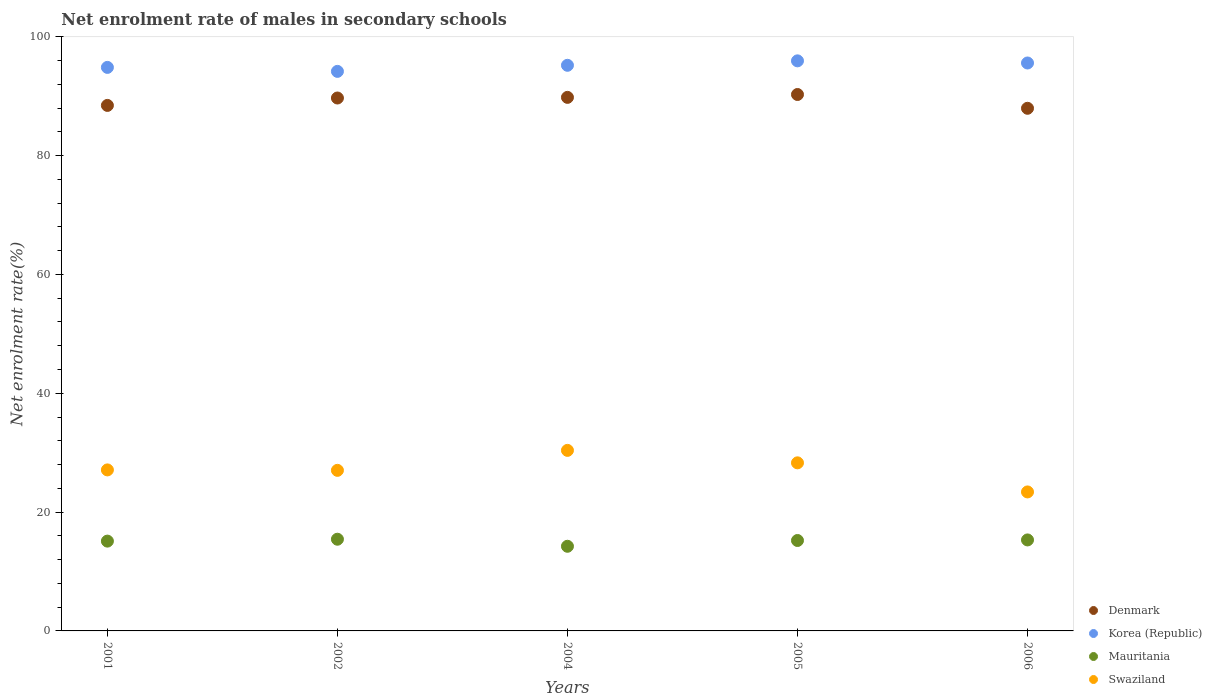How many different coloured dotlines are there?
Ensure brevity in your answer.  4. Is the number of dotlines equal to the number of legend labels?
Offer a terse response. Yes. What is the net enrolment rate of males in secondary schools in Korea (Republic) in 2002?
Offer a very short reply. 94.18. Across all years, what is the maximum net enrolment rate of males in secondary schools in Mauritania?
Provide a succinct answer. 15.43. Across all years, what is the minimum net enrolment rate of males in secondary schools in Swaziland?
Provide a succinct answer. 23.39. In which year was the net enrolment rate of males in secondary schools in Korea (Republic) maximum?
Offer a terse response. 2005. In which year was the net enrolment rate of males in secondary schools in Korea (Republic) minimum?
Provide a succinct answer. 2002. What is the total net enrolment rate of males in secondary schools in Denmark in the graph?
Your response must be concise. 446.19. What is the difference between the net enrolment rate of males in secondary schools in Swaziland in 2001 and that in 2002?
Your answer should be very brief. 0.07. What is the difference between the net enrolment rate of males in secondary schools in Swaziland in 2004 and the net enrolment rate of males in secondary schools in Mauritania in 2005?
Provide a short and direct response. 15.17. What is the average net enrolment rate of males in secondary schools in Denmark per year?
Your answer should be very brief. 89.24. In the year 2001, what is the difference between the net enrolment rate of males in secondary schools in Mauritania and net enrolment rate of males in secondary schools in Swaziland?
Offer a very short reply. -11.99. In how many years, is the net enrolment rate of males in secondary schools in Korea (Republic) greater than 12 %?
Ensure brevity in your answer.  5. What is the ratio of the net enrolment rate of males in secondary schools in Mauritania in 2005 to that in 2006?
Your answer should be very brief. 0.99. Is the difference between the net enrolment rate of males in secondary schools in Mauritania in 2002 and 2004 greater than the difference between the net enrolment rate of males in secondary schools in Swaziland in 2002 and 2004?
Give a very brief answer. Yes. What is the difference between the highest and the second highest net enrolment rate of males in secondary schools in Mauritania?
Your answer should be very brief. 0.12. What is the difference between the highest and the lowest net enrolment rate of males in secondary schools in Mauritania?
Provide a succinct answer. 1.19. Is the sum of the net enrolment rate of males in secondary schools in Mauritania in 2004 and 2005 greater than the maximum net enrolment rate of males in secondary schools in Swaziland across all years?
Offer a terse response. No. How many dotlines are there?
Ensure brevity in your answer.  4. How many years are there in the graph?
Give a very brief answer. 5. Are the values on the major ticks of Y-axis written in scientific E-notation?
Offer a very short reply. No. Does the graph contain grids?
Offer a terse response. No. What is the title of the graph?
Offer a terse response. Net enrolment rate of males in secondary schools. Does "Bhutan" appear as one of the legend labels in the graph?
Keep it short and to the point. No. What is the label or title of the X-axis?
Ensure brevity in your answer.  Years. What is the label or title of the Y-axis?
Your answer should be very brief. Net enrolment rate(%). What is the Net enrolment rate(%) of Denmark in 2001?
Offer a terse response. 88.45. What is the Net enrolment rate(%) in Korea (Republic) in 2001?
Your response must be concise. 94.85. What is the Net enrolment rate(%) of Mauritania in 2001?
Your response must be concise. 15.11. What is the Net enrolment rate(%) of Swaziland in 2001?
Your answer should be compact. 27.1. What is the Net enrolment rate(%) in Denmark in 2002?
Provide a short and direct response. 89.69. What is the Net enrolment rate(%) in Korea (Republic) in 2002?
Provide a short and direct response. 94.18. What is the Net enrolment rate(%) of Mauritania in 2002?
Your answer should be compact. 15.43. What is the Net enrolment rate(%) of Swaziland in 2002?
Make the answer very short. 27.03. What is the Net enrolment rate(%) of Denmark in 2004?
Offer a very short reply. 89.8. What is the Net enrolment rate(%) in Korea (Republic) in 2004?
Your answer should be compact. 95.2. What is the Net enrolment rate(%) of Mauritania in 2004?
Make the answer very short. 14.25. What is the Net enrolment rate(%) of Swaziland in 2004?
Ensure brevity in your answer.  30.39. What is the Net enrolment rate(%) in Denmark in 2005?
Your answer should be compact. 90.28. What is the Net enrolment rate(%) in Korea (Republic) in 2005?
Provide a short and direct response. 95.95. What is the Net enrolment rate(%) in Mauritania in 2005?
Your answer should be compact. 15.22. What is the Net enrolment rate(%) of Swaziland in 2005?
Make the answer very short. 28.29. What is the Net enrolment rate(%) of Denmark in 2006?
Provide a succinct answer. 87.96. What is the Net enrolment rate(%) of Korea (Republic) in 2006?
Offer a very short reply. 95.59. What is the Net enrolment rate(%) of Mauritania in 2006?
Your answer should be very brief. 15.31. What is the Net enrolment rate(%) of Swaziland in 2006?
Your answer should be very brief. 23.39. Across all years, what is the maximum Net enrolment rate(%) in Denmark?
Provide a succinct answer. 90.28. Across all years, what is the maximum Net enrolment rate(%) of Korea (Republic)?
Ensure brevity in your answer.  95.95. Across all years, what is the maximum Net enrolment rate(%) in Mauritania?
Your answer should be very brief. 15.43. Across all years, what is the maximum Net enrolment rate(%) of Swaziland?
Your response must be concise. 30.39. Across all years, what is the minimum Net enrolment rate(%) of Denmark?
Keep it short and to the point. 87.96. Across all years, what is the minimum Net enrolment rate(%) in Korea (Republic)?
Provide a short and direct response. 94.18. Across all years, what is the minimum Net enrolment rate(%) in Mauritania?
Your answer should be compact. 14.25. Across all years, what is the minimum Net enrolment rate(%) of Swaziland?
Keep it short and to the point. 23.39. What is the total Net enrolment rate(%) of Denmark in the graph?
Make the answer very short. 446.19. What is the total Net enrolment rate(%) in Korea (Republic) in the graph?
Ensure brevity in your answer.  475.75. What is the total Net enrolment rate(%) of Mauritania in the graph?
Provide a short and direct response. 75.33. What is the total Net enrolment rate(%) in Swaziland in the graph?
Make the answer very short. 136.19. What is the difference between the Net enrolment rate(%) of Denmark in 2001 and that in 2002?
Offer a very short reply. -1.25. What is the difference between the Net enrolment rate(%) of Korea (Republic) in 2001 and that in 2002?
Provide a succinct answer. 0.67. What is the difference between the Net enrolment rate(%) in Mauritania in 2001 and that in 2002?
Your answer should be compact. -0.32. What is the difference between the Net enrolment rate(%) in Swaziland in 2001 and that in 2002?
Ensure brevity in your answer.  0.07. What is the difference between the Net enrolment rate(%) of Denmark in 2001 and that in 2004?
Offer a very short reply. -1.35. What is the difference between the Net enrolment rate(%) of Korea (Republic) in 2001 and that in 2004?
Offer a terse response. -0.35. What is the difference between the Net enrolment rate(%) of Mauritania in 2001 and that in 2004?
Your answer should be compact. 0.87. What is the difference between the Net enrolment rate(%) in Swaziland in 2001 and that in 2004?
Provide a succinct answer. -3.29. What is the difference between the Net enrolment rate(%) of Denmark in 2001 and that in 2005?
Make the answer very short. -1.84. What is the difference between the Net enrolment rate(%) of Korea (Republic) in 2001 and that in 2005?
Your response must be concise. -1.1. What is the difference between the Net enrolment rate(%) of Mauritania in 2001 and that in 2005?
Keep it short and to the point. -0.1. What is the difference between the Net enrolment rate(%) in Swaziland in 2001 and that in 2005?
Keep it short and to the point. -1.19. What is the difference between the Net enrolment rate(%) in Denmark in 2001 and that in 2006?
Offer a very short reply. 0.48. What is the difference between the Net enrolment rate(%) in Korea (Republic) in 2001 and that in 2006?
Give a very brief answer. -0.74. What is the difference between the Net enrolment rate(%) in Mauritania in 2001 and that in 2006?
Keep it short and to the point. -0.2. What is the difference between the Net enrolment rate(%) of Swaziland in 2001 and that in 2006?
Provide a short and direct response. 3.71. What is the difference between the Net enrolment rate(%) of Denmark in 2002 and that in 2004?
Keep it short and to the point. -0.11. What is the difference between the Net enrolment rate(%) in Korea (Republic) in 2002 and that in 2004?
Ensure brevity in your answer.  -1.02. What is the difference between the Net enrolment rate(%) in Mauritania in 2002 and that in 2004?
Give a very brief answer. 1.19. What is the difference between the Net enrolment rate(%) in Swaziland in 2002 and that in 2004?
Offer a very short reply. -3.36. What is the difference between the Net enrolment rate(%) of Denmark in 2002 and that in 2005?
Ensure brevity in your answer.  -0.59. What is the difference between the Net enrolment rate(%) in Korea (Republic) in 2002 and that in 2005?
Make the answer very short. -1.77. What is the difference between the Net enrolment rate(%) of Mauritania in 2002 and that in 2005?
Keep it short and to the point. 0.21. What is the difference between the Net enrolment rate(%) in Swaziland in 2002 and that in 2005?
Ensure brevity in your answer.  -1.26. What is the difference between the Net enrolment rate(%) in Denmark in 2002 and that in 2006?
Ensure brevity in your answer.  1.73. What is the difference between the Net enrolment rate(%) in Korea (Republic) in 2002 and that in 2006?
Offer a very short reply. -1.41. What is the difference between the Net enrolment rate(%) of Mauritania in 2002 and that in 2006?
Your answer should be compact. 0.12. What is the difference between the Net enrolment rate(%) of Swaziland in 2002 and that in 2006?
Your answer should be compact. 3.63. What is the difference between the Net enrolment rate(%) of Denmark in 2004 and that in 2005?
Offer a very short reply. -0.48. What is the difference between the Net enrolment rate(%) of Korea (Republic) in 2004 and that in 2005?
Your response must be concise. -0.75. What is the difference between the Net enrolment rate(%) of Mauritania in 2004 and that in 2005?
Your answer should be very brief. -0.97. What is the difference between the Net enrolment rate(%) of Swaziland in 2004 and that in 2005?
Your response must be concise. 2.1. What is the difference between the Net enrolment rate(%) in Denmark in 2004 and that in 2006?
Offer a very short reply. 1.84. What is the difference between the Net enrolment rate(%) in Korea (Republic) in 2004 and that in 2006?
Your answer should be very brief. -0.39. What is the difference between the Net enrolment rate(%) in Mauritania in 2004 and that in 2006?
Give a very brief answer. -1.07. What is the difference between the Net enrolment rate(%) in Swaziland in 2004 and that in 2006?
Your answer should be very brief. 6.99. What is the difference between the Net enrolment rate(%) in Denmark in 2005 and that in 2006?
Your response must be concise. 2.32. What is the difference between the Net enrolment rate(%) in Korea (Republic) in 2005 and that in 2006?
Your response must be concise. 0.36. What is the difference between the Net enrolment rate(%) of Mauritania in 2005 and that in 2006?
Your answer should be compact. -0.1. What is the difference between the Net enrolment rate(%) in Swaziland in 2005 and that in 2006?
Offer a very short reply. 4.9. What is the difference between the Net enrolment rate(%) of Denmark in 2001 and the Net enrolment rate(%) of Korea (Republic) in 2002?
Make the answer very short. -5.73. What is the difference between the Net enrolment rate(%) of Denmark in 2001 and the Net enrolment rate(%) of Mauritania in 2002?
Your answer should be very brief. 73.01. What is the difference between the Net enrolment rate(%) of Denmark in 2001 and the Net enrolment rate(%) of Swaziland in 2002?
Keep it short and to the point. 61.42. What is the difference between the Net enrolment rate(%) in Korea (Republic) in 2001 and the Net enrolment rate(%) in Mauritania in 2002?
Ensure brevity in your answer.  79.41. What is the difference between the Net enrolment rate(%) of Korea (Republic) in 2001 and the Net enrolment rate(%) of Swaziland in 2002?
Keep it short and to the point. 67.82. What is the difference between the Net enrolment rate(%) in Mauritania in 2001 and the Net enrolment rate(%) in Swaziland in 2002?
Give a very brief answer. -11.91. What is the difference between the Net enrolment rate(%) in Denmark in 2001 and the Net enrolment rate(%) in Korea (Republic) in 2004?
Ensure brevity in your answer.  -6.75. What is the difference between the Net enrolment rate(%) of Denmark in 2001 and the Net enrolment rate(%) of Mauritania in 2004?
Your response must be concise. 74.2. What is the difference between the Net enrolment rate(%) in Denmark in 2001 and the Net enrolment rate(%) in Swaziland in 2004?
Ensure brevity in your answer.  58.06. What is the difference between the Net enrolment rate(%) in Korea (Republic) in 2001 and the Net enrolment rate(%) in Mauritania in 2004?
Your response must be concise. 80.6. What is the difference between the Net enrolment rate(%) in Korea (Republic) in 2001 and the Net enrolment rate(%) in Swaziland in 2004?
Give a very brief answer. 64.46. What is the difference between the Net enrolment rate(%) in Mauritania in 2001 and the Net enrolment rate(%) in Swaziland in 2004?
Offer a very short reply. -15.27. What is the difference between the Net enrolment rate(%) in Denmark in 2001 and the Net enrolment rate(%) in Korea (Republic) in 2005?
Keep it short and to the point. -7.5. What is the difference between the Net enrolment rate(%) in Denmark in 2001 and the Net enrolment rate(%) in Mauritania in 2005?
Your answer should be very brief. 73.23. What is the difference between the Net enrolment rate(%) in Denmark in 2001 and the Net enrolment rate(%) in Swaziland in 2005?
Provide a succinct answer. 60.16. What is the difference between the Net enrolment rate(%) of Korea (Republic) in 2001 and the Net enrolment rate(%) of Mauritania in 2005?
Provide a short and direct response. 79.63. What is the difference between the Net enrolment rate(%) of Korea (Republic) in 2001 and the Net enrolment rate(%) of Swaziland in 2005?
Offer a very short reply. 66.56. What is the difference between the Net enrolment rate(%) of Mauritania in 2001 and the Net enrolment rate(%) of Swaziland in 2005?
Your answer should be compact. -13.18. What is the difference between the Net enrolment rate(%) in Denmark in 2001 and the Net enrolment rate(%) in Korea (Republic) in 2006?
Ensure brevity in your answer.  -7.14. What is the difference between the Net enrolment rate(%) in Denmark in 2001 and the Net enrolment rate(%) in Mauritania in 2006?
Offer a very short reply. 73.13. What is the difference between the Net enrolment rate(%) in Denmark in 2001 and the Net enrolment rate(%) in Swaziland in 2006?
Offer a terse response. 65.05. What is the difference between the Net enrolment rate(%) in Korea (Republic) in 2001 and the Net enrolment rate(%) in Mauritania in 2006?
Offer a terse response. 79.53. What is the difference between the Net enrolment rate(%) in Korea (Republic) in 2001 and the Net enrolment rate(%) in Swaziland in 2006?
Give a very brief answer. 71.45. What is the difference between the Net enrolment rate(%) of Mauritania in 2001 and the Net enrolment rate(%) of Swaziland in 2006?
Keep it short and to the point. -8.28. What is the difference between the Net enrolment rate(%) of Denmark in 2002 and the Net enrolment rate(%) of Korea (Republic) in 2004?
Offer a terse response. -5.51. What is the difference between the Net enrolment rate(%) of Denmark in 2002 and the Net enrolment rate(%) of Mauritania in 2004?
Your answer should be compact. 75.45. What is the difference between the Net enrolment rate(%) of Denmark in 2002 and the Net enrolment rate(%) of Swaziland in 2004?
Your answer should be very brief. 59.31. What is the difference between the Net enrolment rate(%) in Korea (Republic) in 2002 and the Net enrolment rate(%) in Mauritania in 2004?
Offer a terse response. 79.93. What is the difference between the Net enrolment rate(%) of Korea (Republic) in 2002 and the Net enrolment rate(%) of Swaziland in 2004?
Ensure brevity in your answer.  63.79. What is the difference between the Net enrolment rate(%) in Mauritania in 2002 and the Net enrolment rate(%) in Swaziland in 2004?
Offer a very short reply. -14.95. What is the difference between the Net enrolment rate(%) in Denmark in 2002 and the Net enrolment rate(%) in Korea (Republic) in 2005?
Your response must be concise. -6.26. What is the difference between the Net enrolment rate(%) in Denmark in 2002 and the Net enrolment rate(%) in Mauritania in 2005?
Keep it short and to the point. 74.47. What is the difference between the Net enrolment rate(%) of Denmark in 2002 and the Net enrolment rate(%) of Swaziland in 2005?
Provide a succinct answer. 61.4. What is the difference between the Net enrolment rate(%) of Korea (Republic) in 2002 and the Net enrolment rate(%) of Mauritania in 2005?
Make the answer very short. 78.96. What is the difference between the Net enrolment rate(%) of Korea (Republic) in 2002 and the Net enrolment rate(%) of Swaziland in 2005?
Ensure brevity in your answer.  65.89. What is the difference between the Net enrolment rate(%) in Mauritania in 2002 and the Net enrolment rate(%) in Swaziland in 2005?
Provide a succinct answer. -12.86. What is the difference between the Net enrolment rate(%) of Denmark in 2002 and the Net enrolment rate(%) of Korea (Republic) in 2006?
Provide a short and direct response. -5.89. What is the difference between the Net enrolment rate(%) in Denmark in 2002 and the Net enrolment rate(%) in Mauritania in 2006?
Your answer should be very brief. 74.38. What is the difference between the Net enrolment rate(%) in Denmark in 2002 and the Net enrolment rate(%) in Swaziland in 2006?
Your answer should be very brief. 66.3. What is the difference between the Net enrolment rate(%) of Korea (Republic) in 2002 and the Net enrolment rate(%) of Mauritania in 2006?
Make the answer very short. 78.86. What is the difference between the Net enrolment rate(%) of Korea (Republic) in 2002 and the Net enrolment rate(%) of Swaziland in 2006?
Provide a succinct answer. 70.78. What is the difference between the Net enrolment rate(%) of Mauritania in 2002 and the Net enrolment rate(%) of Swaziland in 2006?
Ensure brevity in your answer.  -7.96. What is the difference between the Net enrolment rate(%) in Denmark in 2004 and the Net enrolment rate(%) in Korea (Republic) in 2005?
Offer a very short reply. -6.15. What is the difference between the Net enrolment rate(%) of Denmark in 2004 and the Net enrolment rate(%) of Mauritania in 2005?
Your answer should be compact. 74.58. What is the difference between the Net enrolment rate(%) in Denmark in 2004 and the Net enrolment rate(%) in Swaziland in 2005?
Offer a terse response. 61.51. What is the difference between the Net enrolment rate(%) of Korea (Republic) in 2004 and the Net enrolment rate(%) of Mauritania in 2005?
Give a very brief answer. 79.98. What is the difference between the Net enrolment rate(%) of Korea (Republic) in 2004 and the Net enrolment rate(%) of Swaziland in 2005?
Provide a short and direct response. 66.91. What is the difference between the Net enrolment rate(%) of Mauritania in 2004 and the Net enrolment rate(%) of Swaziland in 2005?
Ensure brevity in your answer.  -14.04. What is the difference between the Net enrolment rate(%) in Denmark in 2004 and the Net enrolment rate(%) in Korea (Republic) in 2006?
Provide a succinct answer. -5.79. What is the difference between the Net enrolment rate(%) in Denmark in 2004 and the Net enrolment rate(%) in Mauritania in 2006?
Offer a terse response. 74.49. What is the difference between the Net enrolment rate(%) of Denmark in 2004 and the Net enrolment rate(%) of Swaziland in 2006?
Offer a very short reply. 66.41. What is the difference between the Net enrolment rate(%) of Korea (Republic) in 2004 and the Net enrolment rate(%) of Mauritania in 2006?
Your response must be concise. 79.88. What is the difference between the Net enrolment rate(%) in Korea (Republic) in 2004 and the Net enrolment rate(%) in Swaziland in 2006?
Ensure brevity in your answer.  71.81. What is the difference between the Net enrolment rate(%) in Mauritania in 2004 and the Net enrolment rate(%) in Swaziland in 2006?
Offer a very short reply. -9.15. What is the difference between the Net enrolment rate(%) in Denmark in 2005 and the Net enrolment rate(%) in Korea (Republic) in 2006?
Give a very brief answer. -5.3. What is the difference between the Net enrolment rate(%) of Denmark in 2005 and the Net enrolment rate(%) of Mauritania in 2006?
Ensure brevity in your answer.  74.97. What is the difference between the Net enrolment rate(%) of Denmark in 2005 and the Net enrolment rate(%) of Swaziland in 2006?
Offer a terse response. 66.89. What is the difference between the Net enrolment rate(%) of Korea (Republic) in 2005 and the Net enrolment rate(%) of Mauritania in 2006?
Make the answer very short. 80.63. What is the difference between the Net enrolment rate(%) in Korea (Republic) in 2005 and the Net enrolment rate(%) in Swaziland in 2006?
Give a very brief answer. 72.55. What is the difference between the Net enrolment rate(%) in Mauritania in 2005 and the Net enrolment rate(%) in Swaziland in 2006?
Provide a short and direct response. -8.17. What is the average Net enrolment rate(%) in Denmark per year?
Your answer should be very brief. 89.24. What is the average Net enrolment rate(%) of Korea (Republic) per year?
Provide a short and direct response. 95.15. What is the average Net enrolment rate(%) of Mauritania per year?
Keep it short and to the point. 15.07. What is the average Net enrolment rate(%) of Swaziland per year?
Keep it short and to the point. 27.24. In the year 2001, what is the difference between the Net enrolment rate(%) in Denmark and Net enrolment rate(%) in Korea (Republic)?
Your answer should be very brief. -6.4. In the year 2001, what is the difference between the Net enrolment rate(%) of Denmark and Net enrolment rate(%) of Mauritania?
Your response must be concise. 73.33. In the year 2001, what is the difference between the Net enrolment rate(%) in Denmark and Net enrolment rate(%) in Swaziland?
Give a very brief answer. 61.35. In the year 2001, what is the difference between the Net enrolment rate(%) in Korea (Republic) and Net enrolment rate(%) in Mauritania?
Provide a short and direct response. 79.73. In the year 2001, what is the difference between the Net enrolment rate(%) of Korea (Republic) and Net enrolment rate(%) of Swaziland?
Provide a short and direct response. 67.75. In the year 2001, what is the difference between the Net enrolment rate(%) of Mauritania and Net enrolment rate(%) of Swaziland?
Make the answer very short. -11.99. In the year 2002, what is the difference between the Net enrolment rate(%) in Denmark and Net enrolment rate(%) in Korea (Republic)?
Make the answer very short. -4.48. In the year 2002, what is the difference between the Net enrolment rate(%) of Denmark and Net enrolment rate(%) of Mauritania?
Give a very brief answer. 74.26. In the year 2002, what is the difference between the Net enrolment rate(%) of Denmark and Net enrolment rate(%) of Swaziland?
Offer a very short reply. 62.67. In the year 2002, what is the difference between the Net enrolment rate(%) in Korea (Republic) and Net enrolment rate(%) in Mauritania?
Offer a very short reply. 78.74. In the year 2002, what is the difference between the Net enrolment rate(%) in Korea (Republic) and Net enrolment rate(%) in Swaziland?
Provide a succinct answer. 67.15. In the year 2002, what is the difference between the Net enrolment rate(%) in Mauritania and Net enrolment rate(%) in Swaziland?
Provide a short and direct response. -11.59. In the year 2004, what is the difference between the Net enrolment rate(%) in Denmark and Net enrolment rate(%) in Korea (Republic)?
Make the answer very short. -5.4. In the year 2004, what is the difference between the Net enrolment rate(%) in Denmark and Net enrolment rate(%) in Mauritania?
Ensure brevity in your answer.  75.55. In the year 2004, what is the difference between the Net enrolment rate(%) in Denmark and Net enrolment rate(%) in Swaziland?
Offer a very short reply. 59.41. In the year 2004, what is the difference between the Net enrolment rate(%) of Korea (Republic) and Net enrolment rate(%) of Mauritania?
Ensure brevity in your answer.  80.95. In the year 2004, what is the difference between the Net enrolment rate(%) of Korea (Republic) and Net enrolment rate(%) of Swaziland?
Your answer should be very brief. 64.81. In the year 2004, what is the difference between the Net enrolment rate(%) in Mauritania and Net enrolment rate(%) in Swaziland?
Make the answer very short. -16.14. In the year 2005, what is the difference between the Net enrolment rate(%) in Denmark and Net enrolment rate(%) in Korea (Republic)?
Give a very brief answer. -5.66. In the year 2005, what is the difference between the Net enrolment rate(%) of Denmark and Net enrolment rate(%) of Mauritania?
Your response must be concise. 75.06. In the year 2005, what is the difference between the Net enrolment rate(%) in Denmark and Net enrolment rate(%) in Swaziland?
Provide a succinct answer. 61.99. In the year 2005, what is the difference between the Net enrolment rate(%) of Korea (Republic) and Net enrolment rate(%) of Mauritania?
Your response must be concise. 80.73. In the year 2005, what is the difference between the Net enrolment rate(%) in Korea (Republic) and Net enrolment rate(%) in Swaziland?
Provide a short and direct response. 67.66. In the year 2005, what is the difference between the Net enrolment rate(%) of Mauritania and Net enrolment rate(%) of Swaziland?
Keep it short and to the point. -13.07. In the year 2006, what is the difference between the Net enrolment rate(%) of Denmark and Net enrolment rate(%) of Korea (Republic)?
Offer a terse response. -7.62. In the year 2006, what is the difference between the Net enrolment rate(%) in Denmark and Net enrolment rate(%) in Mauritania?
Give a very brief answer. 72.65. In the year 2006, what is the difference between the Net enrolment rate(%) in Denmark and Net enrolment rate(%) in Swaziland?
Provide a short and direct response. 64.57. In the year 2006, what is the difference between the Net enrolment rate(%) in Korea (Republic) and Net enrolment rate(%) in Mauritania?
Ensure brevity in your answer.  80.27. In the year 2006, what is the difference between the Net enrolment rate(%) in Korea (Republic) and Net enrolment rate(%) in Swaziland?
Your response must be concise. 72.19. In the year 2006, what is the difference between the Net enrolment rate(%) of Mauritania and Net enrolment rate(%) of Swaziland?
Provide a succinct answer. -8.08. What is the ratio of the Net enrolment rate(%) in Denmark in 2001 to that in 2002?
Your response must be concise. 0.99. What is the ratio of the Net enrolment rate(%) in Korea (Republic) in 2001 to that in 2002?
Make the answer very short. 1.01. What is the ratio of the Net enrolment rate(%) of Mauritania in 2001 to that in 2002?
Offer a very short reply. 0.98. What is the ratio of the Net enrolment rate(%) in Denmark in 2001 to that in 2004?
Ensure brevity in your answer.  0.98. What is the ratio of the Net enrolment rate(%) in Mauritania in 2001 to that in 2004?
Give a very brief answer. 1.06. What is the ratio of the Net enrolment rate(%) of Swaziland in 2001 to that in 2004?
Provide a succinct answer. 0.89. What is the ratio of the Net enrolment rate(%) of Denmark in 2001 to that in 2005?
Offer a very short reply. 0.98. What is the ratio of the Net enrolment rate(%) of Korea (Republic) in 2001 to that in 2005?
Provide a succinct answer. 0.99. What is the ratio of the Net enrolment rate(%) in Swaziland in 2001 to that in 2005?
Your answer should be compact. 0.96. What is the ratio of the Net enrolment rate(%) of Denmark in 2001 to that in 2006?
Provide a short and direct response. 1.01. What is the ratio of the Net enrolment rate(%) of Mauritania in 2001 to that in 2006?
Your response must be concise. 0.99. What is the ratio of the Net enrolment rate(%) in Swaziland in 2001 to that in 2006?
Offer a terse response. 1.16. What is the ratio of the Net enrolment rate(%) of Korea (Republic) in 2002 to that in 2004?
Keep it short and to the point. 0.99. What is the ratio of the Net enrolment rate(%) in Swaziland in 2002 to that in 2004?
Provide a succinct answer. 0.89. What is the ratio of the Net enrolment rate(%) of Korea (Republic) in 2002 to that in 2005?
Offer a very short reply. 0.98. What is the ratio of the Net enrolment rate(%) of Mauritania in 2002 to that in 2005?
Make the answer very short. 1.01. What is the ratio of the Net enrolment rate(%) of Swaziland in 2002 to that in 2005?
Make the answer very short. 0.96. What is the ratio of the Net enrolment rate(%) in Denmark in 2002 to that in 2006?
Your answer should be compact. 1.02. What is the ratio of the Net enrolment rate(%) of Korea (Republic) in 2002 to that in 2006?
Provide a succinct answer. 0.99. What is the ratio of the Net enrolment rate(%) in Swaziland in 2002 to that in 2006?
Provide a succinct answer. 1.16. What is the ratio of the Net enrolment rate(%) of Denmark in 2004 to that in 2005?
Ensure brevity in your answer.  0.99. What is the ratio of the Net enrolment rate(%) of Mauritania in 2004 to that in 2005?
Your answer should be compact. 0.94. What is the ratio of the Net enrolment rate(%) of Swaziland in 2004 to that in 2005?
Your answer should be very brief. 1.07. What is the ratio of the Net enrolment rate(%) of Denmark in 2004 to that in 2006?
Your answer should be very brief. 1.02. What is the ratio of the Net enrolment rate(%) of Mauritania in 2004 to that in 2006?
Offer a very short reply. 0.93. What is the ratio of the Net enrolment rate(%) of Swaziland in 2004 to that in 2006?
Your response must be concise. 1.3. What is the ratio of the Net enrolment rate(%) of Denmark in 2005 to that in 2006?
Provide a short and direct response. 1.03. What is the ratio of the Net enrolment rate(%) in Korea (Republic) in 2005 to that in 2006?
Offer a terse response. 1. What is the ratio of the Net enrolment rate(%) of Swaziland in 2005 to that in 2006?
Your answer should be very brief. 1.21. What is the difference between the highest and the second highest Net enrolment rate(%) in Denmark?
Offer a terse response. 0.48. What is the difference between the highest and the second highest Net enrolment rate(%) in Korea (Republic)?
Offer a very short reply. 0.36. What is the difference between the highest and the second highest Net enrolment rate(%) of Mauritania?
Give a very brief answer. 0.12. What is the difference between the highest and the second highest Net enrolment rate(%) of Swaziland?
Your response must be concise. 2.1. What is the difference between the highest and the lowest Net enrolment rate(%) in Denmark?
Your response must be concise. 2.32. What is the difference between the highest and the lowest Net enrolment rate(%) of Korea (Republic)?
Provide a short and direct response. 1.77. What is the difference between the highest and the lowest Net enrolment rate(%) of Mauritania?
Provide a succinct answer. 1.19. What is the difference between the highest and the lowest Net enrolment rate(%) of Swaziland?
Give a very brief answer. 6.99. 